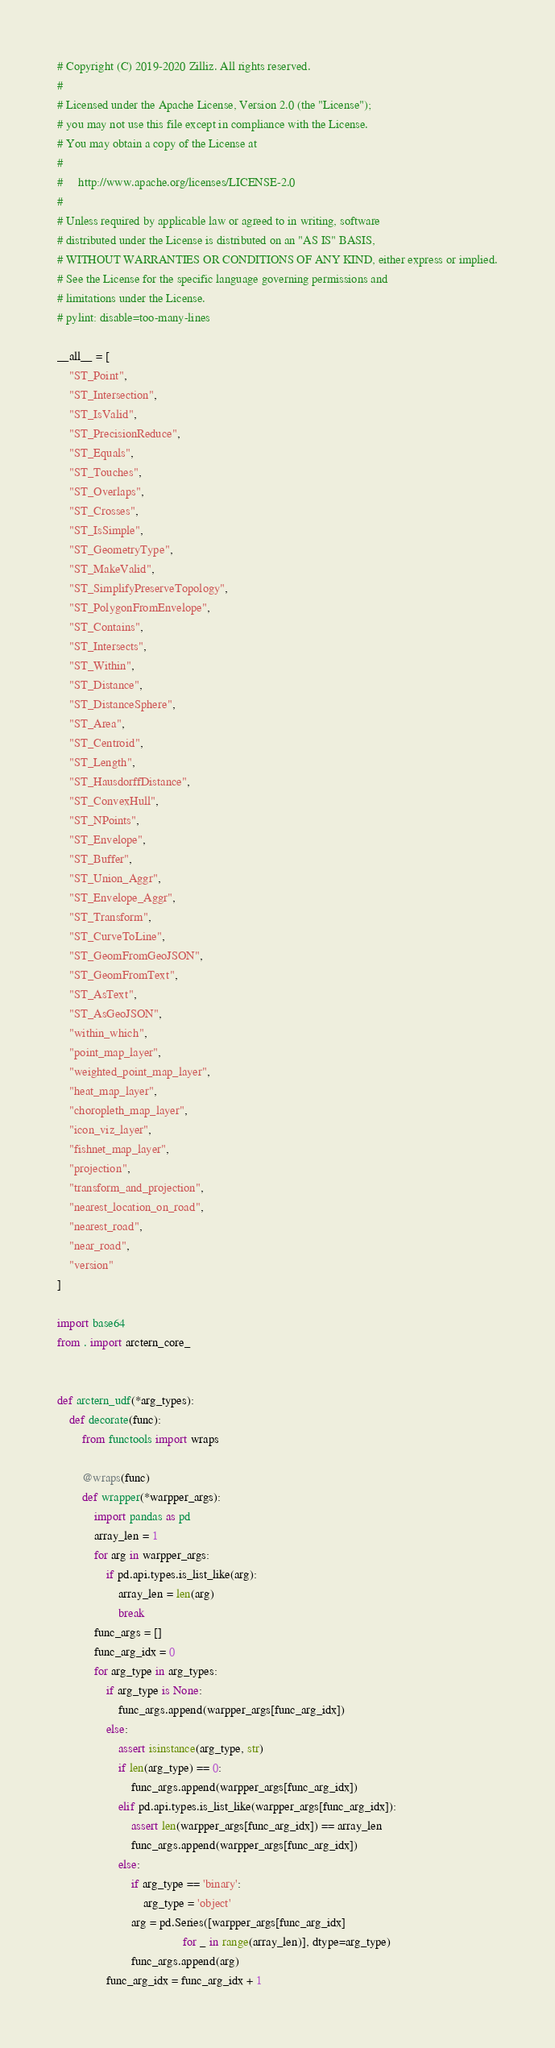<code> <loc_0><loc_0><loc_500><loc_500><_Python_># Copyright (C) 2019-2020 Zilliz. All rights reserved.
#
# Licensed under the Apache License, Version 2.0 (the "License");
# you may not use this file except in compliance with the License.
# You may obtain a copy of the License at
#
#     http://www.apache.org/licenses/LICENSE-2.0
#
# Unless required by applicable law or agreed to in writing, software
# distributed under the License is distributed on an "AS IS" BASIS,
# WITHOUT WARRANTIES OR CONDITIONS OF ANY KIND, either express or implied.
# See the License for the specific language governing permissions and
# limitations under the License.
# pylint: disable=too-many-lines

__all__ = [
    "ST_Point",
    "ST_Intersection",
    "ST_IsValid",
    "ST_PrecisionReduce",
    "ST_Equals",
    "ST_Touches",
    "ST_Overlaps",
    "ST_Crosses",
    "ST_IsSimple",
    "ST_GeometryType",
    "ST_MakeValid",
    "ST_SimplifyPreserveTopology",
    "ST_PolygonFromEnvelope",
    "ST_Contains",
    "ST_Intersects",
    "ST_Within",
    "ST_Distance",
    "ST_DistanceSphere",
    "ST_Area",
    "ST_Centroid",
    "ST_Length",
    "ST_HausdorffDistance",
    "ST_ConvexHull",
    "ST_NPoints",
    "ST_Envelope",
    "ST_Buffer",
    "ST_Union_Aggr",
    "ST_Envelope_Aggr",
    "ST_Transform",
    "ST_CurveToLine",
    "ST_GeomFromGeoJSON",
    "ST_GeomFromText",
    "ST_AsText",
    "ST_AsGeoJSON",
    "within_which",
    "point_map_layer",
    "weighted_point_map_layer",
    "heat_map_layer",
    "choropleth_map_layer",
    "icon_viz_layer",
    "fishnet_map_layer",
    "projection",
    "transform_and_projection",
    "nearest_location_on_road",
    "nearest_road",
    "near_road",
    "version"
]

import base64
from . import arctern_core_


def arctern_udf(*arg_types):
    def decorate(func):
        from functools import wraps

        @wraps(func)
        def wrapper(*warpper_args):
            import pandas as pd
            array_len = 1
            for arg in warpper_args:
                if pd.api.types.is_list_like(arg):
                    array_len = len(arg)
                    break
            func_args = []
            func_arg_idx = 0
            for arg_type in arg_types:
                if arg_type is None:
                    func_args.append(warpper_args[func_arg_idx])
                else:
                    assert isinstance(arg_type, str)
                    if len(arg_type) == 0:
                        func_args.append(warpper_args[func_arg_idx])
                    elif pd.api.types.is_list_like(warpper_args[func_arg_idx]):
                        assert len(warpper_args[func_arg_idx]) == array_len
                        func_args.append(warpper_args[func_arg_idx])
                    else:
                        if arg_type == 'binary':
                            arg_type = 'object'
                        arg = pd.Series([warpper_args[func_arg_idx]
                                         for _ in range(array_len)], dtype=arg_type)
                        func_args.append(arg)
                func_arg_idx = func_arg_idx + 1</code> 